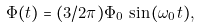<formula> <loc_0><loc_0><loc_500><loc_500>\Phi ( t ) = ( 3 / 2 \pi ) \Phi _ { 0 } \, \sin \, ( \omega _ { 0 } t ) ,</formula> 